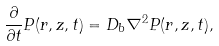Convert formula to latex. <formula><loc_0><loc_0><loc_500><loc_500>\frac { \partial } { \partial t } P ( r , z , t ) = D _ { b } \nabla ^ { 2 } P ( r , z , t ) ,</formula> 